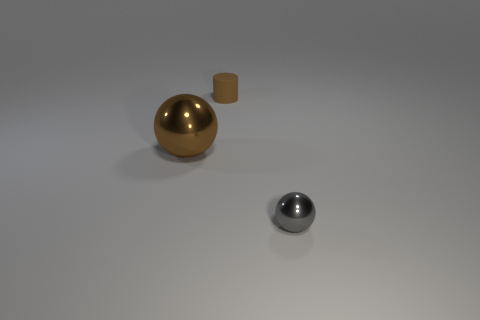Are there any other things that are the same material as the cylinder?
Provide a short and direct response. No. Is there anything else that is the same size as the brown shiny ball?
Offer a very short reply. No. The thing that is the same color as the rubber cylinder is what shape?
Your answer should be very brief. Sphere. Is the color of the shiny sphere that is on the left side of the gray shiny object the same as the rubber cylinder?
Give a very brief answer. Yes. There is a shiny thing that is on the left side of the metal thing that is on the right side of the large brown metal sphere; what shape is it?
Your answer should be compact. Sphere. How many things are either spheres that are in front of the big brown metallic ball or shiny balls that are left of the small gray object?
Your answer should be very brief. 2. The large object that is the same material as the tiny sphere is what shape?
Offer a very short reply. Sphere. Is there any other thing that is the same color as the big metal object?
Your answer should be very brief. Yes. What material is the other object that is the same shape as the large shiny thing?
Provide a succinct answer. Metal. How many other things are the same size as the cylinder?
Make the answer very short. 1. 